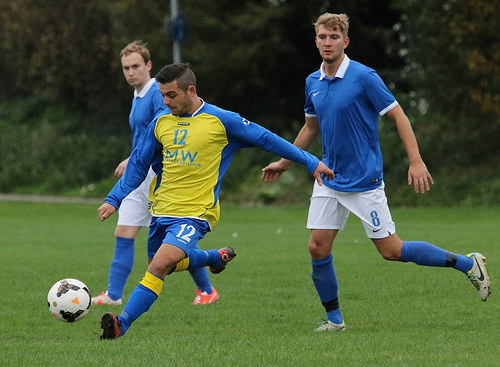<image>
Can you confirm if the ball is on the shoe? No. The ball is not positioned on the shoe. They may be near each other, but the ball is not supported by or resting on top of the shoe. Where is the tree in relation to the man? Is it behind the man? Yes. From this viewpoint, the tree is positioned behind the man, with the man partially or fully occluding the tree. 